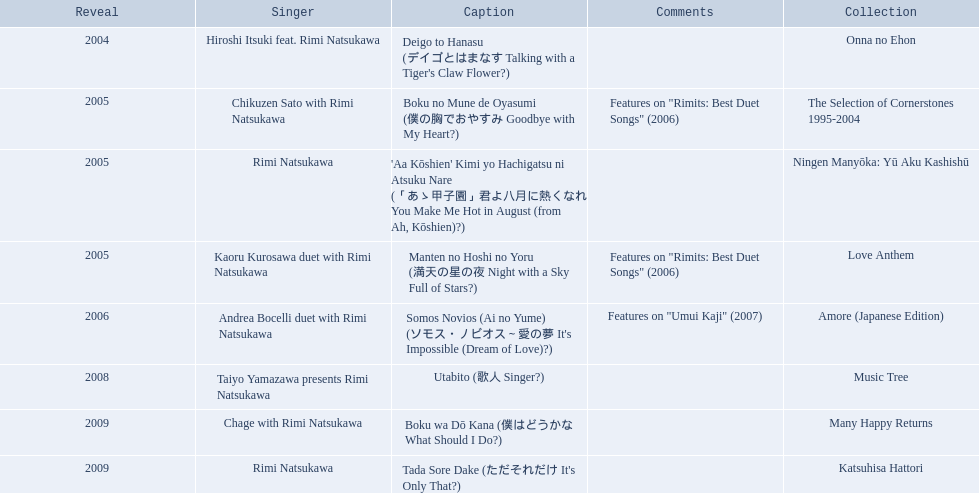What are the notes for sky full of stars? Features on "Rimits: Best Duet Songs" (2006). What other song features this same note? Boku no Mune de Oyasumi (僕の胸でおやすみ Goodbye with My Heart?). 